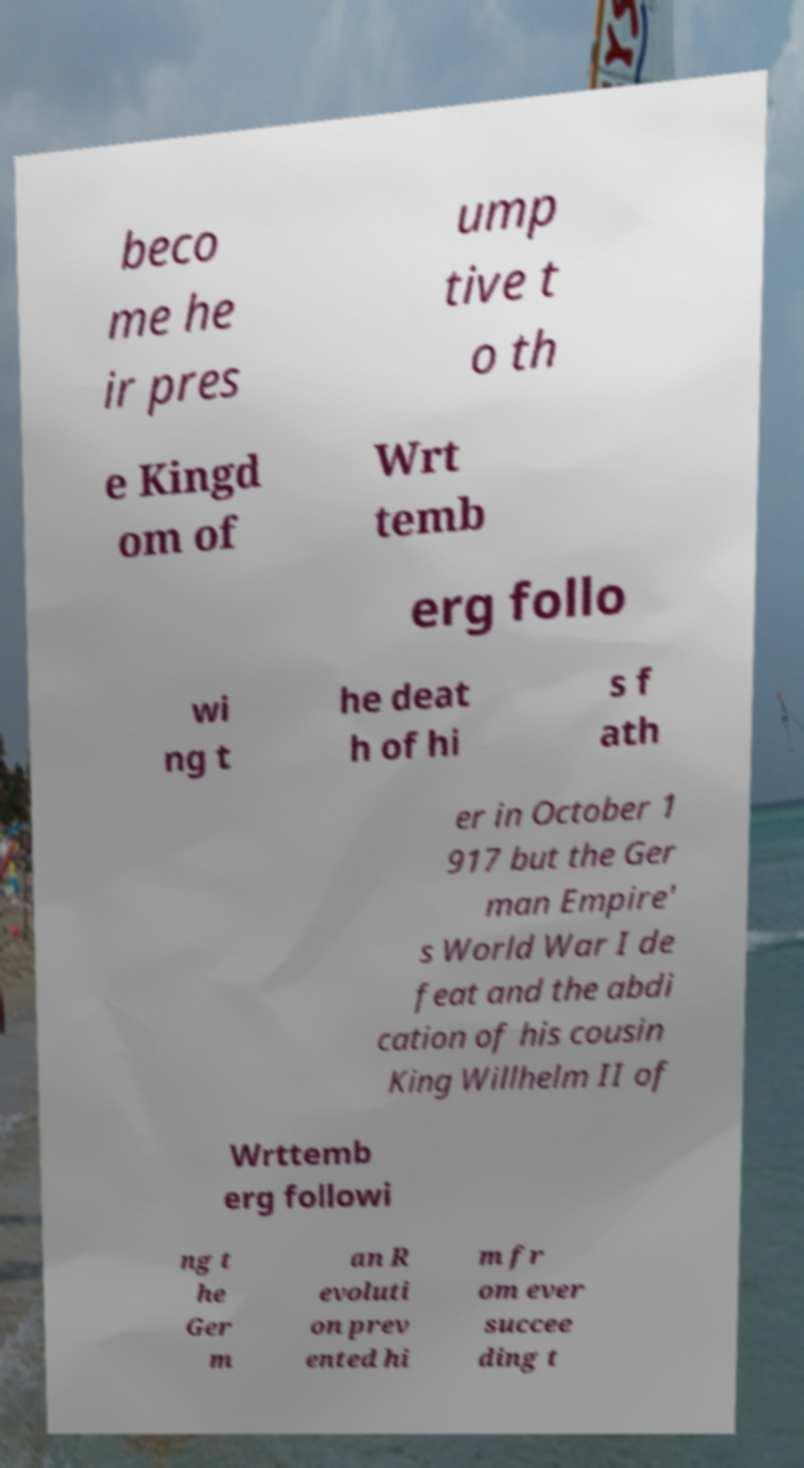Could you extract and type out the text from this image? beco me he ir pres ump tive t o th e Kingd om of Wrt temb erg follo wi ng t he deat h of hi s f ath er in October 1 917 but the Ger man Empire' s World War I de feat and the abdi cation of his cousin King Willhelm II of Wrttemb erg followi ng t he Ger m an R evoluti on prev ented hi m fr om ever succee ding t 